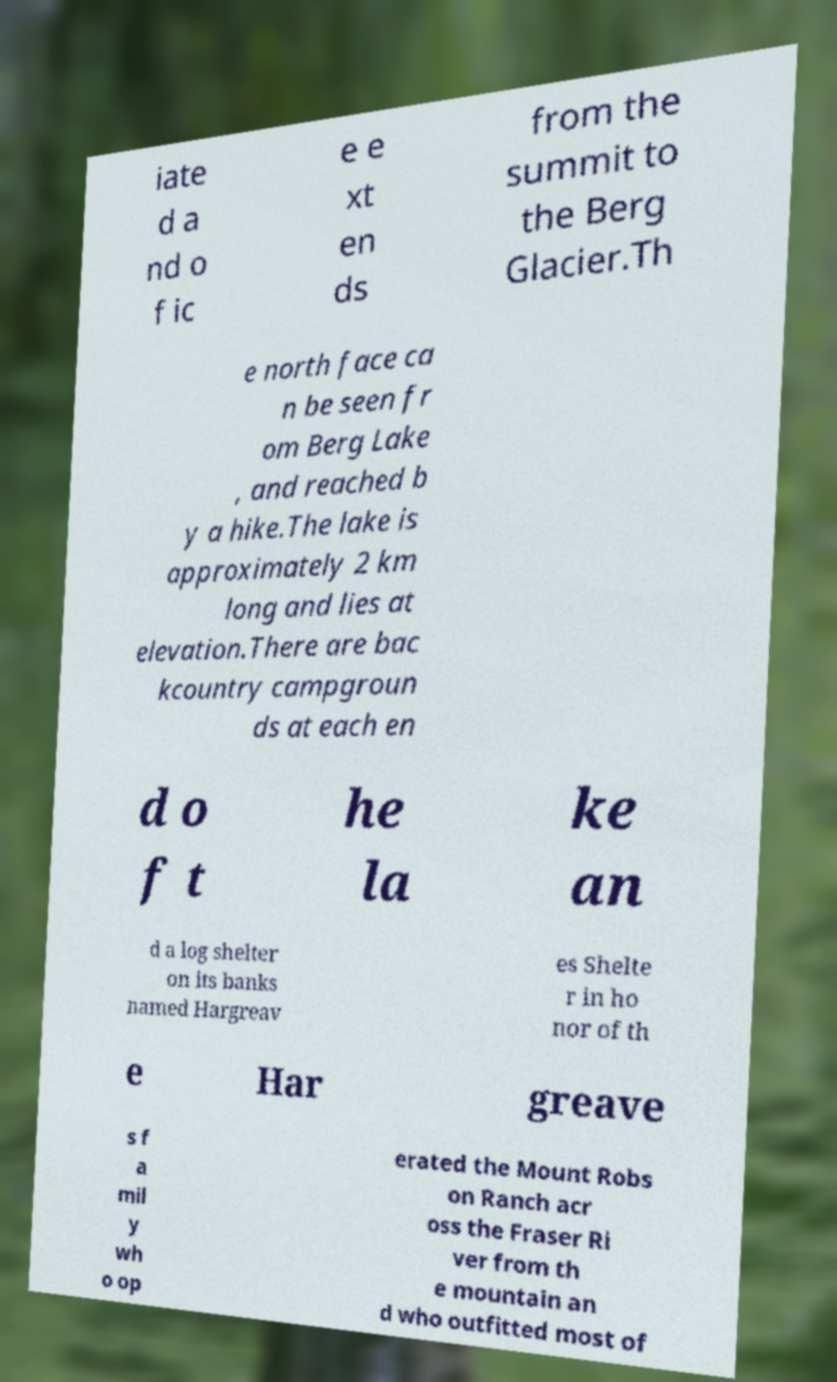For documentation purposes, I need the text within this image transcribed. Could you provide that? iate d a nd o f ic e e xt en ds from the summit to the Berg Glacier.Th e north face ca n be seen fr om Berg Lake , and reached b y a hike.The lake is approximately 2 km long and lies at elevation.There are bac kcountry campgroun ds at each en d o f t he la ke an d a log shelter on its banks named Hargreav es Shelte r in ho nor of th e Har greave s f a mil y wh o op erated the Mount Robs on Ranch acr oss the Fraser Ri ver from th e mountain an d who outfitted most of 